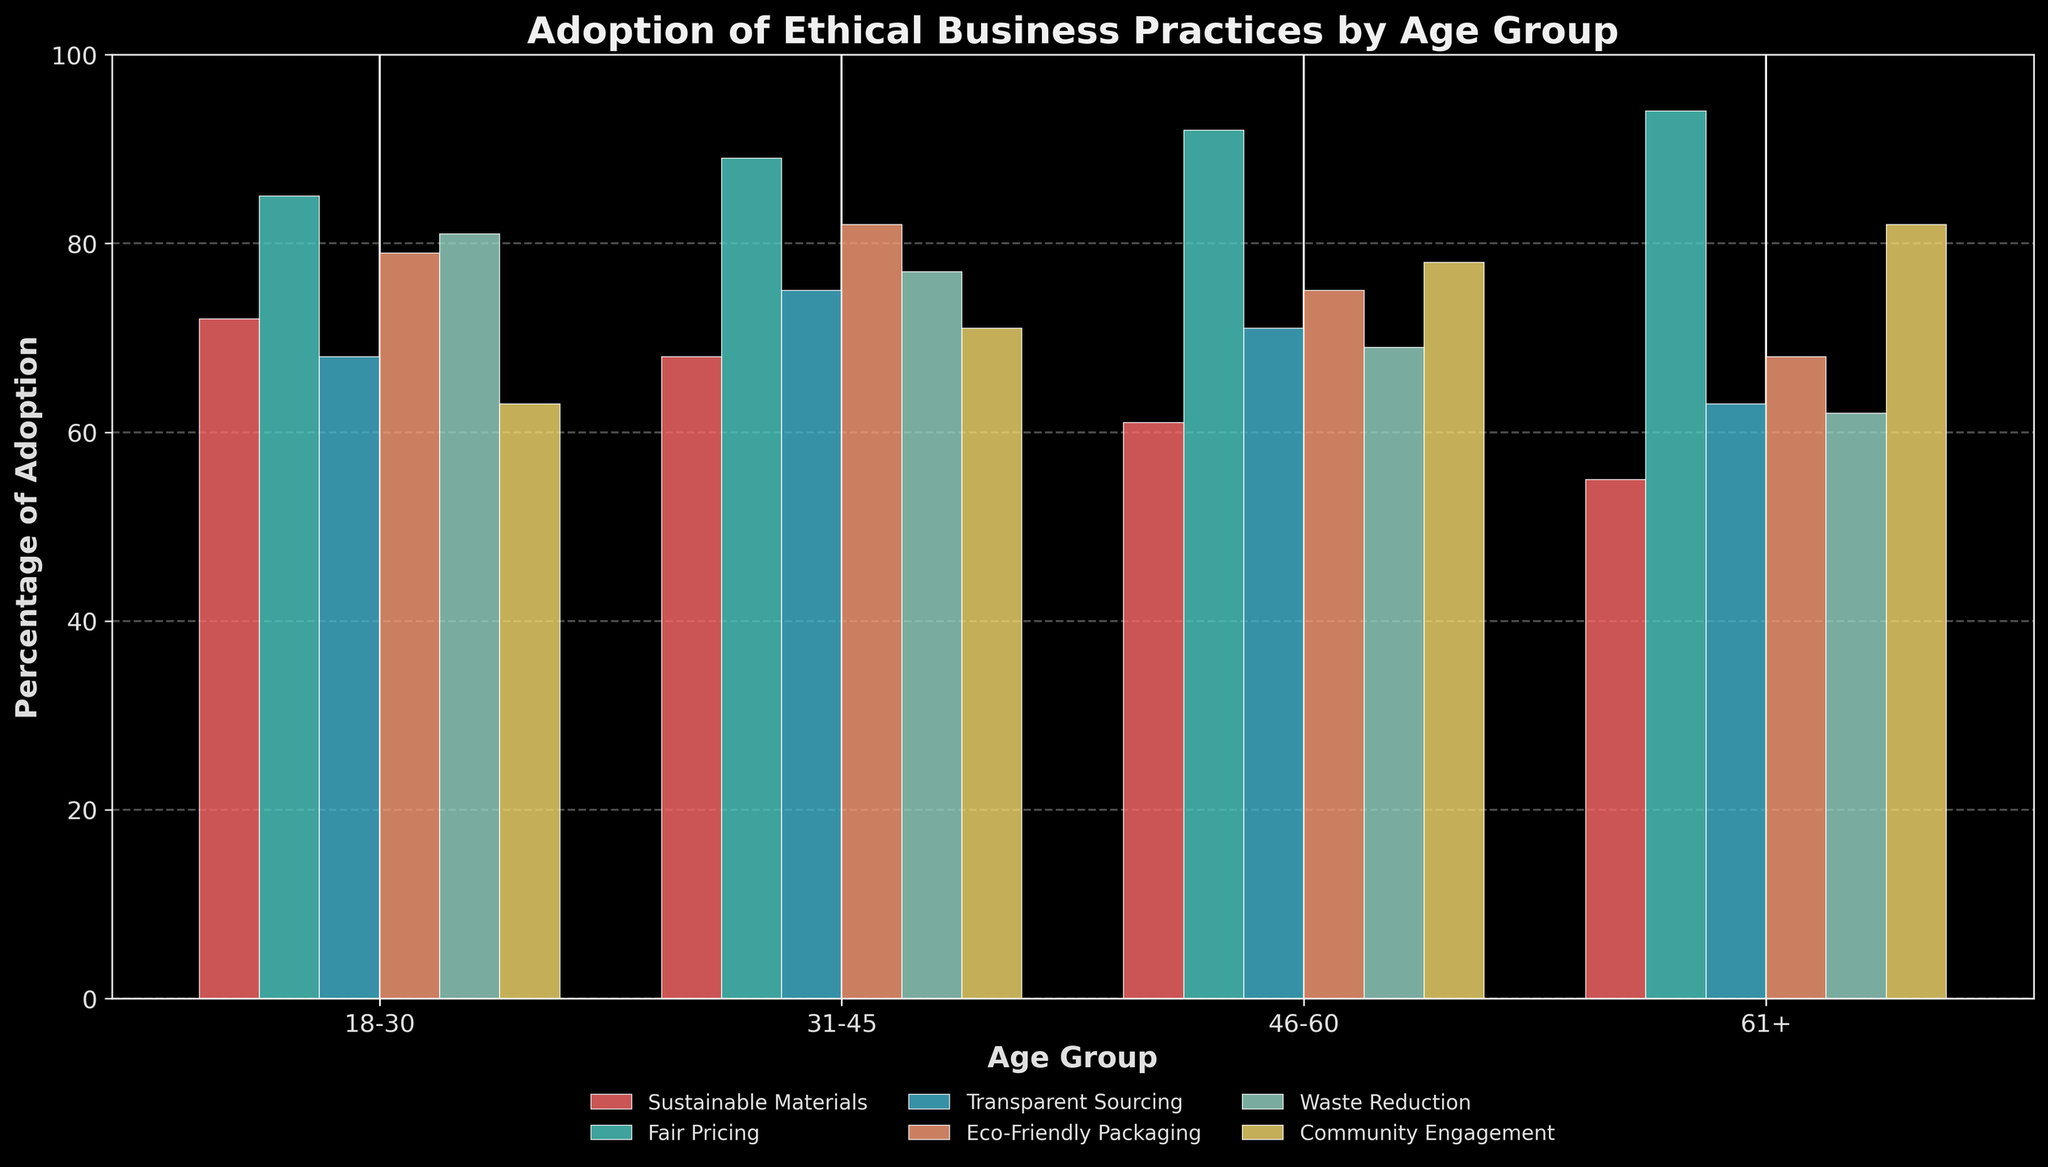Which age group has the highest adoption rate for Fair Pricing? To find the answer, compare the heights of the bars for Fair Pricing across all age groups in the bar chart.
Answer: 61+ Which practice has the lowest adoption rate among the 18-30 age group? Examine the heights of the bars specifically for the 18-30 age group and identify the shortest bar.
Answer: Community Engagement What is the difference in adoption of Sustainable Materials between the 18-30 and 61+ age groups? Find the heights of the Sustainable Materials bars for the 18-30 and 61+ age groups, then subtract the height of the 61+ bar from that of the 18-30 bar: 72 - 55 = 17.
Answer: 17 Which age group shows the largest variation in adoption rates across all practices? Identify the group with the widest range between the highest and lowest adoption rates for all practices. Calculate the range for each age group and compare: 
18-30: 85 - 63 = 22
31-45: 89 - 68 = 21
46-60: 92 - 61 = 31
61+: 94 - 55 = 39
The 61+ age group has the largest variation.
Answer: 61+ Which practice is most consistently adopted across all age groups? Evaluate each practice by examining the ranges (difference between the highest and lowest values) across all age groups. The practice with the smallest range is the most consistent:
Sustainable Materials: 72 - 55 = 17
Fair Pricing: 94 - 85 = 9
Transparent Sourcing: 75 - 63 = 12
Eco-Friendly Packaging: 82 - 68 = 14
Waste Reduction: 81 - 62 = 19
Community Engagement: 82 - 63 = 19
Fair Pricing has the smallest range.
Answer: Fair Pricing 